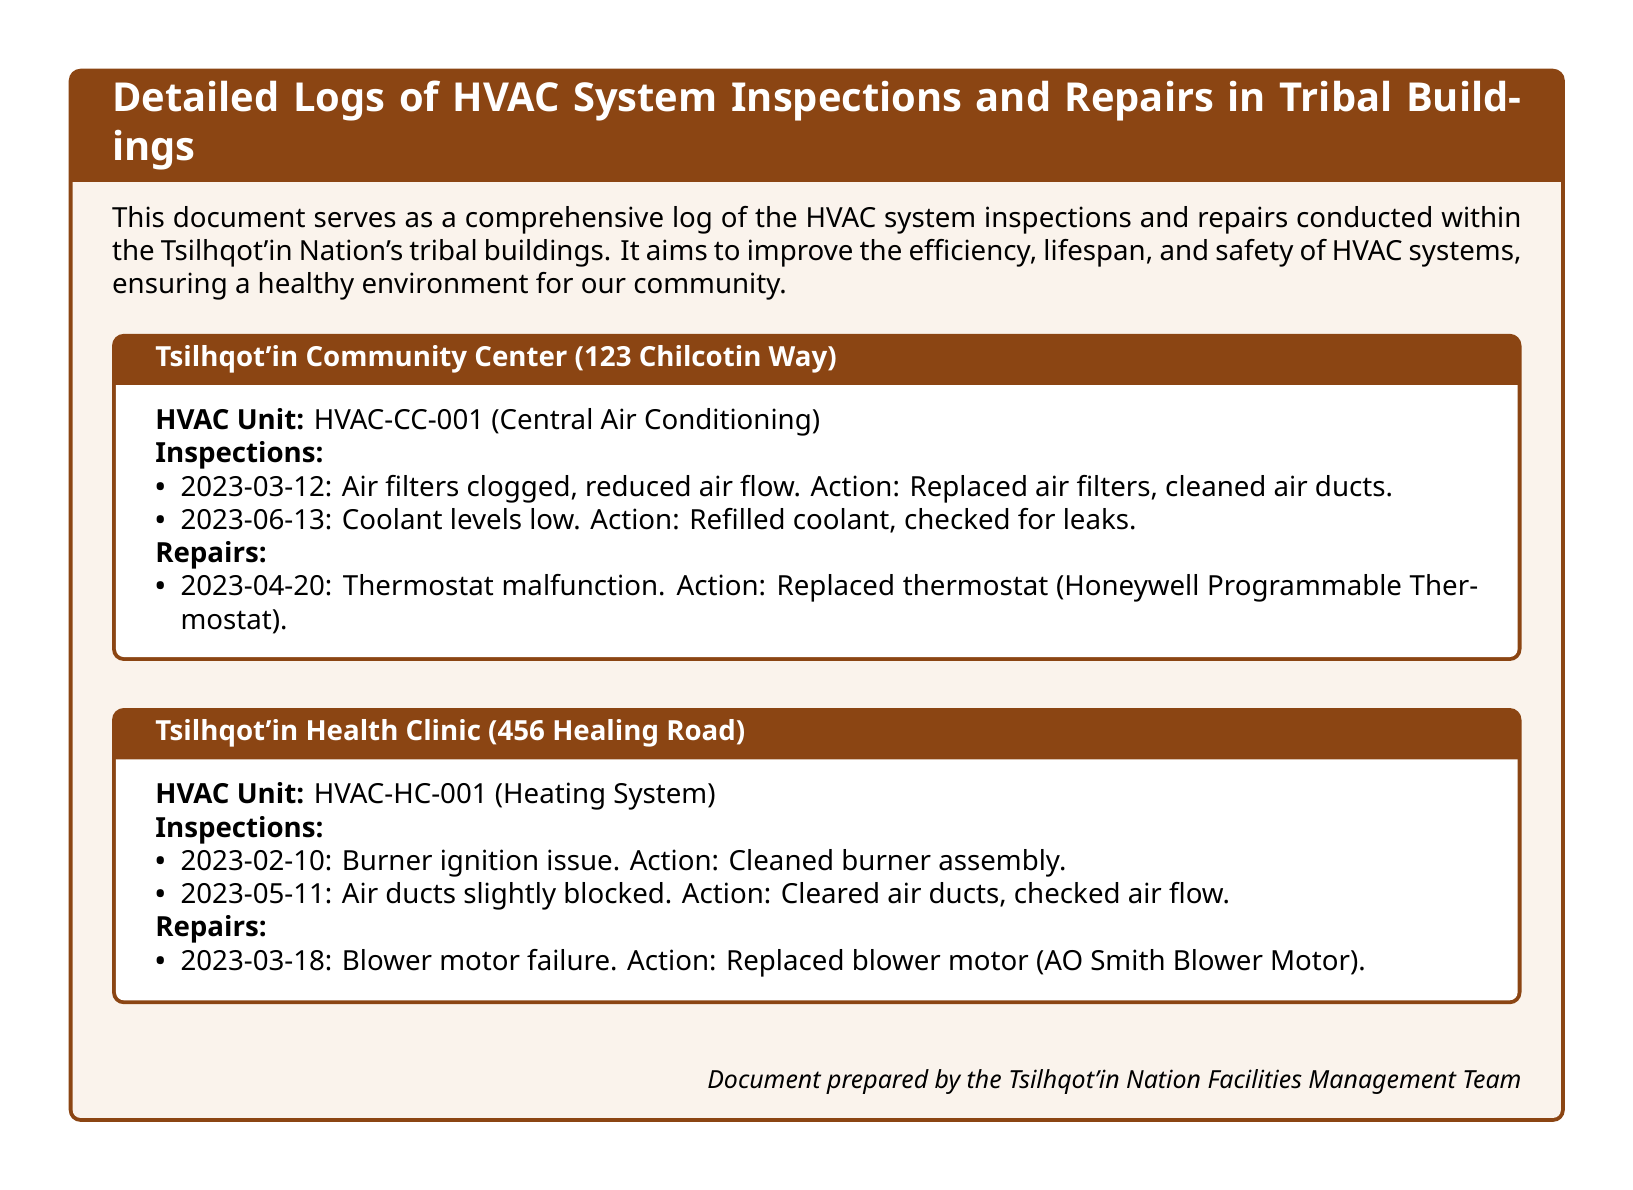What is the HVAC unit number for the Tsilhqot'in Community Center? The HVAC unit number is specified at the beginning of the log for the Tsilhqot'in Community Center.
Answer: HVAC-CC-001 When was the blower motor replaced at the Health Clinic? The date of the blower motor replacement is noted under the repairs section of the Health Clinic's log.
Answer: 2023-03-18 What action was taken due to clogged air filters at the Community Center? The action for clogged air filters is listed in the inspections section of the Community Center's log.
Answer: Replaced air filters, cleaned air ducts How many inspections were logged for the HVAC system in the Health Clinic? The number of inspections can be counted from the list provided in the Health Clinic's log.
Answer: 2 What brand of thermostat was replaced at the Community Center? The brand and type of the thermostat replaced is explicitly stated in the repairs section.
Answer: Honeywell Programmable Thermostat Which component failed in the heating system at the Health Clinic? The specific failure is detailed in the repairs section of the Health Clinic's log.
Answer: Blower motor What was low during the inspection on June 13 at the Community Center? The item that was indicated as low is described during the inspection details.
Answer: Coolant levels Which date had the air ducts cleared at the Health Clinic? The date for this action can be found in the inspections section of the Health Clinic's log.
Answer: 2023-05-11 